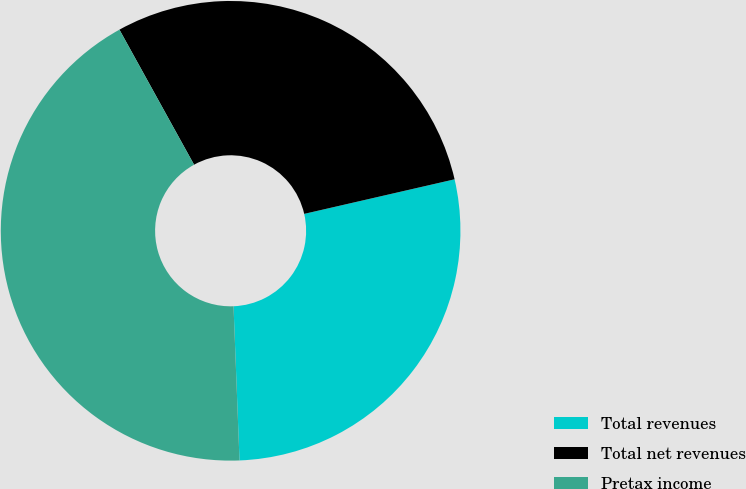<chart> <loc_0><loc_0><loc_500><loc_500><pie_chart><fcel>Total revenues<fcel>Total net revenues<fcel>Pretax income<nl><fcel>27.98%<fcel>29.44%<fcel>42.58%<nl></chart> 